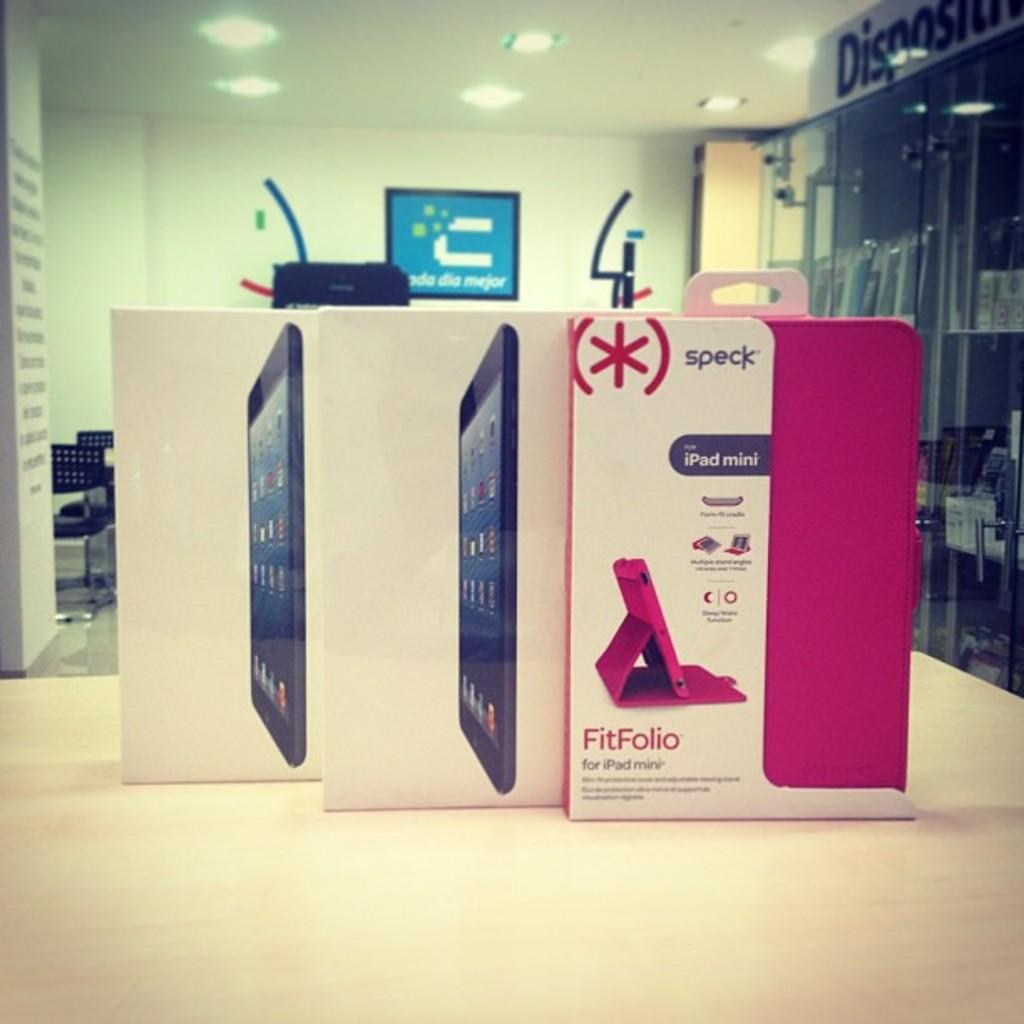<image>
Relay a brief, clear account of the picture shown. Two iPad minis are in a box on a table next to a FitFolio case. 